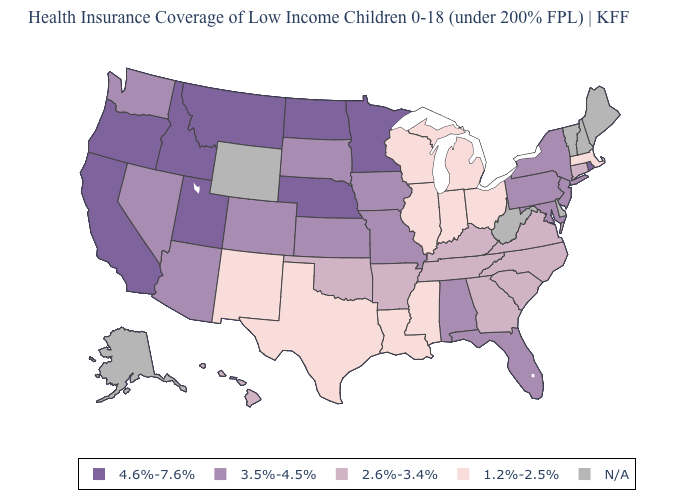Which states have the highest value in the USA?
Give a very brief answer. California, Idaho, Minnesota, Montana, Nebraska, North Dakota, Oregon, Rhode Island, Utah. Which states have the highest value in the USA?
Be succinct. California, Idaho, Minnesota, Montana, Nebraska, North Dakota, Oregon, Rhode Island, Utah. Which states have the lowest value in the West?
Write a very short answer. New Mexico. Which states have the lowest value in the USA?
Keep it brief. Illinois, Indiana, Louisiana, Massachusetts, Michigan, Mississippi, New Mexico, Ohio, Texas, Wisconsin. Among the states that border Connecticut , does Massachusetts have the highest value?
Answer briefly. No. What is the value of California?
Keep it brief. 4.6%-7.6%. Among the states that border Pennsylvania , does Maryland have the highest value?
Short answer required. Yes. What is the highest value in the USA?
Quick response, please. 4.6%-7.6%. Which states have the lowest value in the USA?
Be succinct. Illinois, Indiana, Louisiana, Massachusetts, Michigan, Mississippi, New Mexico, Ohio, Texas, Wisconsin. Name the states that have a value in the range 3.5%-4.5%?
Keep it brief. Alabama, Arizona, Colorado, Florida, Iowa, Kansas, Maryland, Missouri, Nevada, New Jersey, New York, Pennsylvania, South Dakota, Washington. Does California have the highest value in the USA?
Answer briefly. Yes. Is the legend a continuous bar?
Quick response, please. No. Which states have the lowest value in the West?
Write a very short answer. New Mexico. 